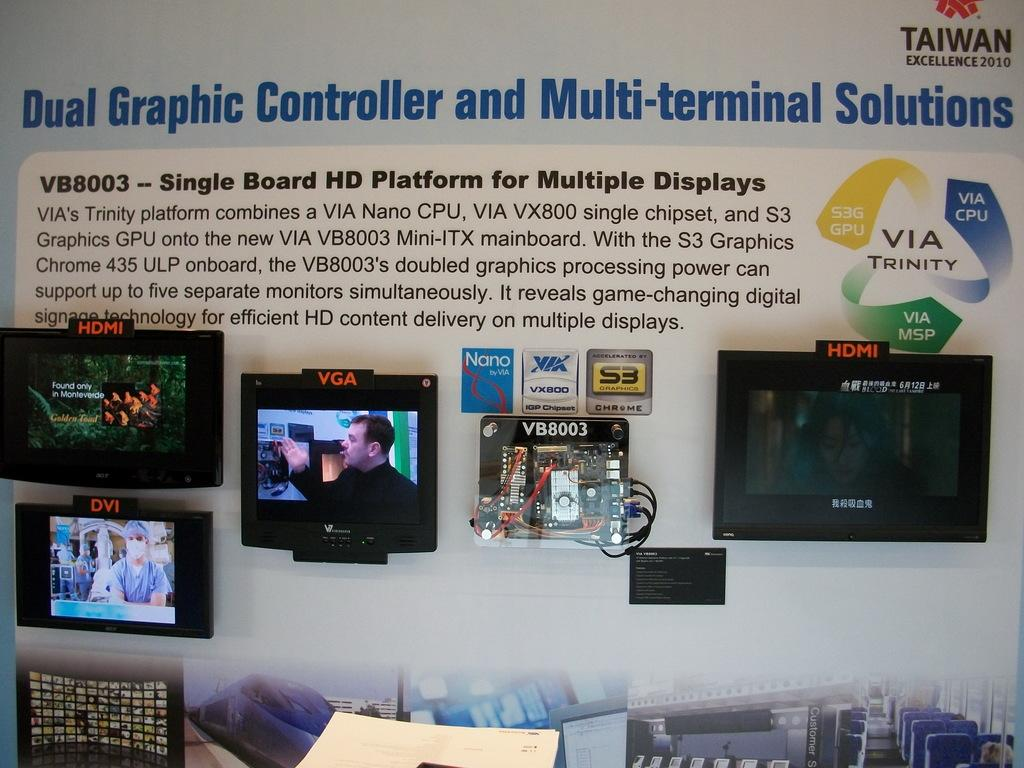<image>
Present a compact description of the photo's key features. A wall has a display with monitors and says Dual Graphic Controller and Multi-terminal Solutions. 